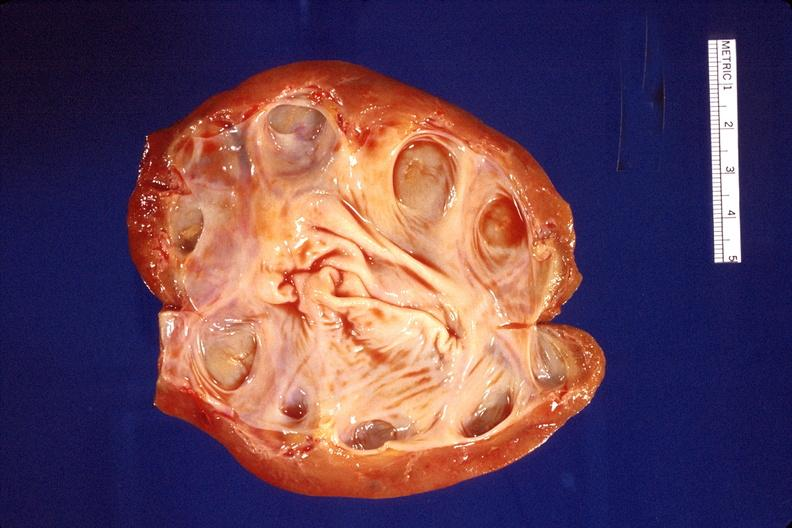where is this?
Answer the question using a single word or phrase. Urinary 